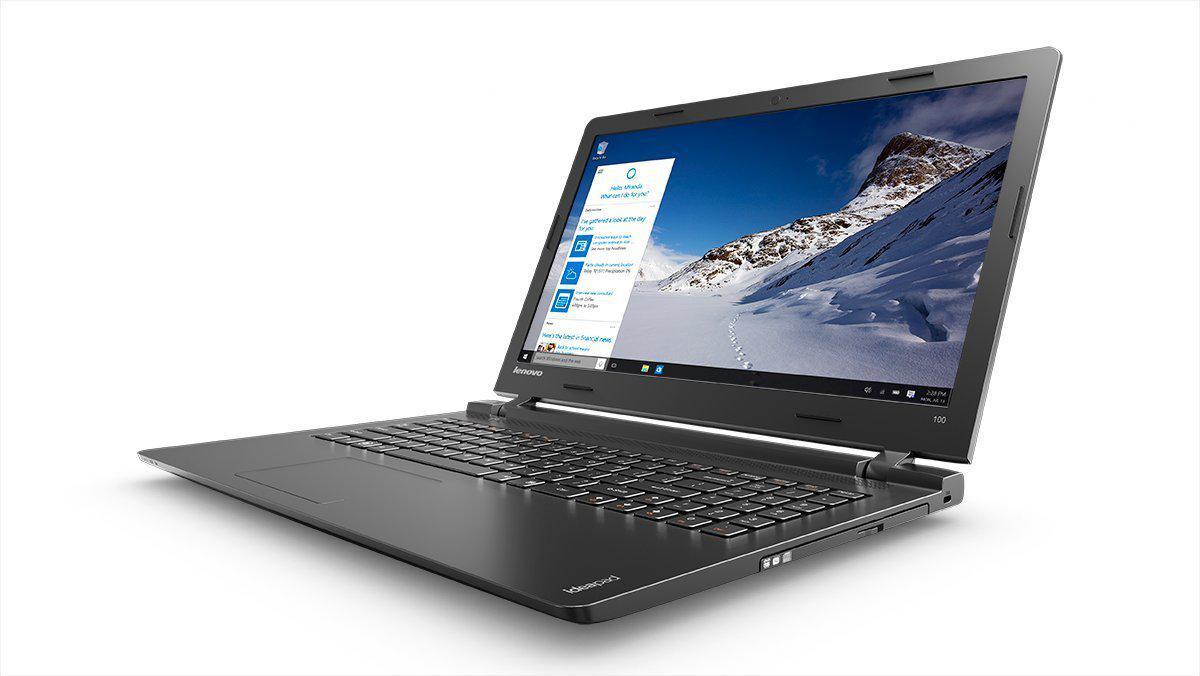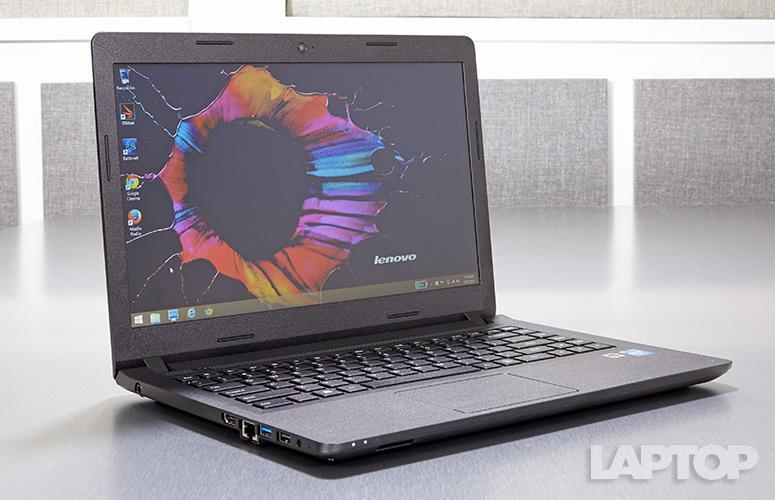The first image is the image on the left, the second image is the image on the right. Considering the images on both sides, is "One of the displays shows a mountain." valid? Answer yes or no. Yes. The first image is the image on the left, the second image is the image on the right. Examine the images to the left and right. Is the description "Each image contains one laptop opened to at least 90-degrees with its screen visible." accurate? Answer yes or no. Yes. 